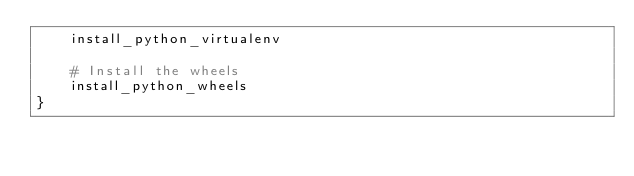<code> <loc_0><loc_0><loc_500><loc_500><_Bash_>    install_python_virtualenv

    # Install the wheels
    install_python_wheels
}

</code> 